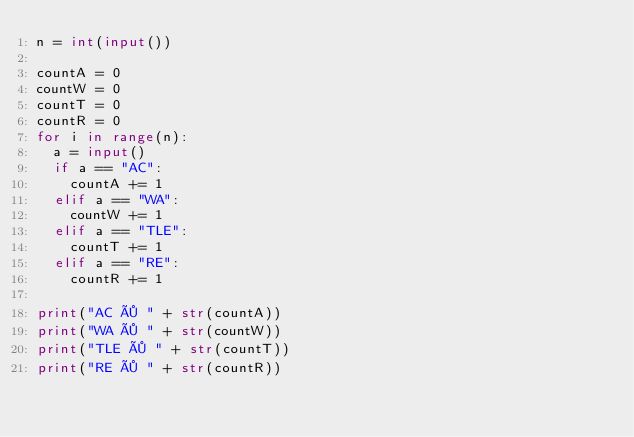Convert code to text. <code><loc_0><loc_0><loc_500><loc_500><_Python_>n = int(input())

countA = 0
countW = 0
countT = 0
countR = 0
for i in range(n):
  a = input()
  if a == "AC":
    countA += 1
  elif a == "WA":
    countW += 1
  elif a == "TLE":
    countT += 1
  elif a == "RE":
    countR += 1

print("AC × " + str(countA))
print("WA × " + str(countW))
print("TLE × " + str(countT))
print("RE × " + str(countR))
    </code> 